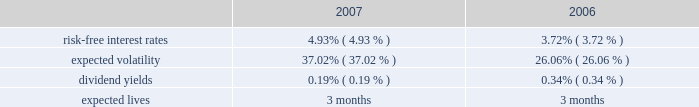Notes to consolidated financial statements 2014 ( continued ) the weighted average grant-date fair value of share awards granted in the years ended may 31 , 2007 and 2006 was $ 45 and $ 36 , respectively .
The total fair value of share awards vested during the years ended may 31 , 2008 , 2007 and 2006 was $ 4.1 million , $ 1.7 million and $ 1.4 million , respectively .
We recognized compensation expenses for restricted stock of $ 5.7 million , $ 2.7 million , and $ 1.6 million in the years ended may 31 , 2008 , 2007 and 2006 .
As of may 31 , 2008 , there was $ 15.2 million of total unrecognized compensation cost related to unvested restricted stock awards that is expected to be recognized over a weighted average period of 2.9 years .
Employee stock purchase plan we have an employee stock purchase plan under which the sale of 2.4 million shares of our common stock has been authorized .
Employees may designate up to the lesser of $ 25 thousand or 20% ( 20 % ) of their annual compensation for the purchase of stock .
For periods prior to october 1 , 2006 , the price for shares purchased under the plan was the lower of 85% ( 85 % ) of the market value on the first day or the last day of the quarterly purchase period .
With the quarterly purchase period beginning on october 1 , 2006 , the price for shares purchased under the plan is 85% ( 85 % ) of the market value on the last day of the quarterly purchase period ( the 201cpurchase date 201d ) .
At may 31 , 2008 , 0.7 million shares had been issued under this plan , with 1.7 million shares reserved for future issuance .
The weighted average grant-date fair value of each designated share purchased under this plan was $ 6 , $ 8 and $ 8 in the years ended may 31 , 2008 , 2007 and 2006 , respectively .
For the quarterly purchases after october 1 , 2006 , the fair value of each designated share purchased under the employee stock purchase plan is based on the 15% ( 15 % ) discount on the purchase date .
For purchases prior to october 1 , 2006 , the fair value of each designated share purchased under the employee stock purchase plan was estimated on the date of grant using the black-scholes valuation model using the following weighted average assumptions: .
The risk-free interest rate is based on the yield of a zero coupon united states treasury security with a maturity equal to the expected life of the option from the date of the grant .
Our assumption on expected volatility is based on our historical volatility .
The dividend yield assumption is calculated using our average stock price over the preceding year and the annualized amount of our current quarterly dividend .
Since the purchase price for shares under the plan is based on the market value on the first day or last day of the quarterly purchase period , we use an expected life of three months to determine the fair value of each designated share. .
In 2008 , how much of the compensation will be used on stock purchases if the employees used 20% ( 20 % ) of their compensation? 
Rationale: in line 6 , it states that employees may designate 20% of their compensation for stock purchases . the question asks the total amount of money the employees would use on stock purchases if each employee used 20% .
Computations: (5.7 * 20%)
Answer: 1.14. 